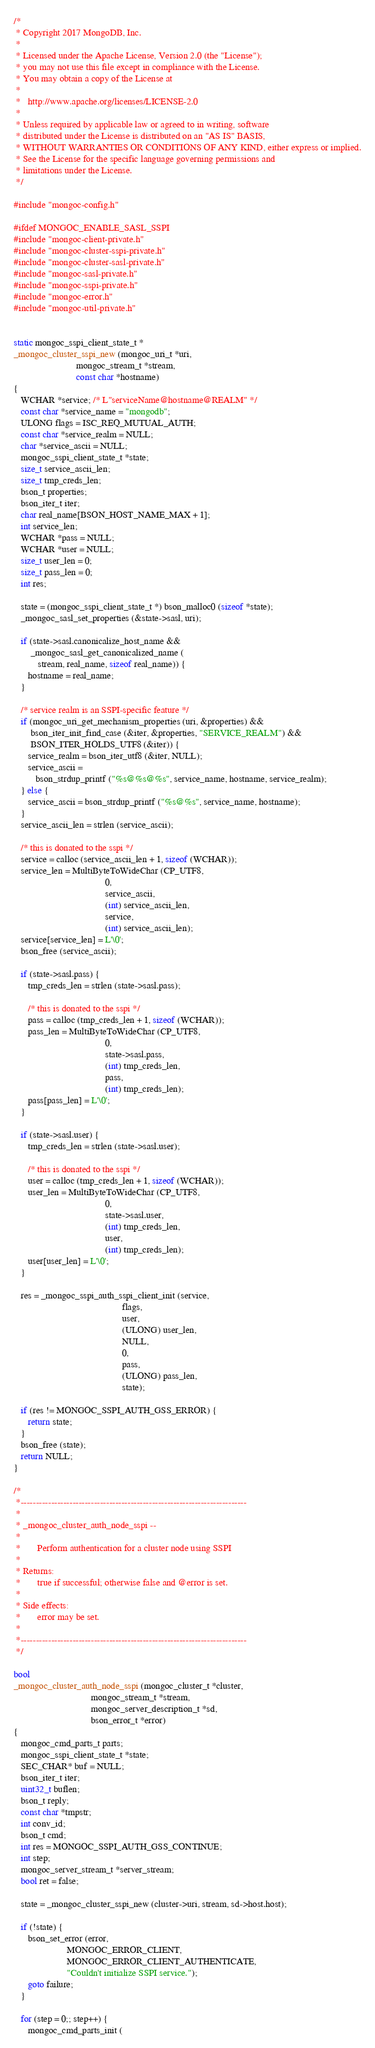Convert code to text. <code><loc_0><loc_0><loc_500><loc_500><_C_>/*
 * Copyright 2017 MongoDB, Inc.
 *
 * Licensed under the Apache License, Version 2.0 (the "License");
 * you may not use this file except in compliance with the License.
 * You may obtain a copy of the License at
 *
 *   http://www.apache.org/licenses/LICENSE-2.0
 *
 * Unless required by applicable law or agreed to in writing, software
 * distributed under the License is distributed on an "AS IS" BASIS,
 * WITHOUT WARRANTIES OR CONDITIONS OF ANY KIND, either express or implied.
 * See the License for the specific language governing permissions and
 * limitations under the License.
 */

#include "mongoc-config.h"

#ifdef MONGOC_ENABLE_SASL_SSPI
#include "mongoc-client-private.h"
#include "mongoc-cluster-sspi-private.h"
#include "mongoc-cluster-sasl-private.h"
#include "mongoc-sasl-private.h"
#include "mongoc-sspi-private.h"
#include "mongoc-error.h"
#include "mongoc-util-private.h"


static mongoc_sspi_client_state_t *
_mongoc_cluster_sspi_new (mongoc_uri_t *uri,
                          mongoc_stream_t *stream,
                          const char *hostname)
{
   WCHAR *service; /* L"serviceName@hostname@REALM" */
   const char *service_name = "mongodb";
   ULONG flags = ISC_REQ_MUTUAL_AUTH;
   const char *service_realm = NULL;
   char *service_ascii = NULL;
   mongoc_sspi_client_state_t *state;
   size_t service_ascii_len;
   size_t tmp_creds_len;
   bson_t properties;
   bson_iter_t iter;
   char real_name[BSON_HOST_NAME_MAX + 1];
   int service_len;
   WCHAR *pass = NULL;
   WCHAR *user = NULL;
   size_t user_len = 0;
   size_t pass_len = 0;
   int res;

   state = (mongoc_sspi_client_state_t *) bson_malloc0 (sizeof *state);
   _mongoc_sasl_set_properties (&state->sasl, uri);

   if (state->sasl.canonicalize_host_name &&
       _mongoc_sasl_get_canonicalized_name (
          stream, real_name, sizeof real_name)) {
      hostname = real_name;
   }

   /* service realm is an SSPI-specific feature */
   if (mongoc_uri_get_mechanism_properties (uri, &properties) &&
       bson_iter_init_find_case (&iter, &properties, "SERVICE_REALM") &&
       BSON_ITER_HOLDS_UTF8 (&iter)) {
      service_realm = bson_iter_utf8 (&iter, NULL);
      service_ascii =
         bson_strdup_printf ("%s@%s@%s", service_name, hostname, service_realm);
   } else {
      service_ascii = bson_strdup_printf ("%s@%s", service_name, hostname);
   }
   service_ascii_len = strlen (service_ascii);

   /* this is donated to the sspi */
   service = calloc (service_ascii_len + 1, sizeof (WCHAR));
   service_len = MultiByteToWideChar (CP_UTF8,
                                      0,
                                      service_ascii,
                                      (int) service_ascii_len,
                                      service,
                                      (int) service_ascii_len);
   service[service_len] = L'\0';
   bson_free (service_ascii);

   if (state->sasl.pass) {
      tmp_creds_len = strlen (state->sasl.pass);

      /* this is donated to the sspi */
      pass = calloc (tmp_creds_len + 1, sizeof (WCHAR));
      pass_len = MultiByteToWideChar (CP_UTF8,
                                      0,
                                      state->sasl.pass,
                                      (int) tmp_creds_len,
                                      pass,
                                      (int) tmp_creds_len);
      pass[pass_len] = L'\0';
   }

   if (state->sasl.user) {
      tmp_creds_len = strlen (state->sasl.user);

      /* this is donated to the sspi */
      user = calloc (tmp_creds_len + 1, sizeof (WCHAR));
      user_len = MultiByteToWideChar (CP_UTF8,
                                      0,
                                      state->sasl.user,
                                      (int) tmp_creds_len,
                                      user,
                                      (int) tmp_creds_len);
      user[user_len] = L'\0';
   }

   res = _mongoc_sspi_auth_sspi_client_init (service,
                                             flags,
                                             user,
                                             (ULONG) user_len,
                                             NULL,
                                             0,
                                             pass,
                                             (ULONG) pass_len,
                                             state);

   if (res != MONGOC_SSPI_AUTH_GSS_ERROR) {
      return state;
   }
   bson_free (state);
   return NULL;
}

/*
 *--------------------------------------------------------------------------
 *
 * _mongoc_cluster_auth_node_sspi --
 *
 *       Perform authentication for a cluster node using SSPI
 *
 * Returns:
 *       true if successful; otherwise false and @error is set.
 *
 * Side effects:
 *       error may be set.
 *
 *--------------------------------------------------------------------------
 */

bool
_mongoc_cluster_auth_node_sspi (mongoc_cluster_t *cluster,
                                mongoc_stream_t *stream,
                                mongoc_server_description_t *sd,
                                bson_error_t *error)
{
   mongoc_cmd_parts_t parts;
   mongoc_sspi_client_state_t *state;
   SEC_CHAR* buf = NULL;
   bson_iter_t iter;
   uint32_t buflen;
   bson_t reply;
   const char *tmpstr;
   int conv_id;
   bson_t cmd;
   int res = MONGOC_SSPI_AUTH_GSS_CONTINUE;
   int step;
   mongoc_server_stream_t *server_stream;
   bool ret = false;

   state = _mongoc_cluster_sspi_new (cluster->uri, stream, sd->host.host);

   if (!state) {
      bson_set_error (error,
                      MONGOC_ERROR_CLIENT,
                      MONGOC_ERROR_CLIENT_AUTHENTICATE,
                      "Couldn't initialize SSPI service.");
      goto failure;
   }

   for (step = 0;; step++) {
      mongoc_cmd_parts_init (</code> 